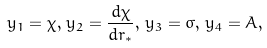Convert formula to latex. <formula><loc_0><loc_0><loc_500><loc_500>y _ { 1 } = \chi , \, y _ { 2 } = \frac { d \chi } { d r _ { * } } , \, y _ { 3 } = \sigma , \, y _ { 4 } = A ,</formula> 